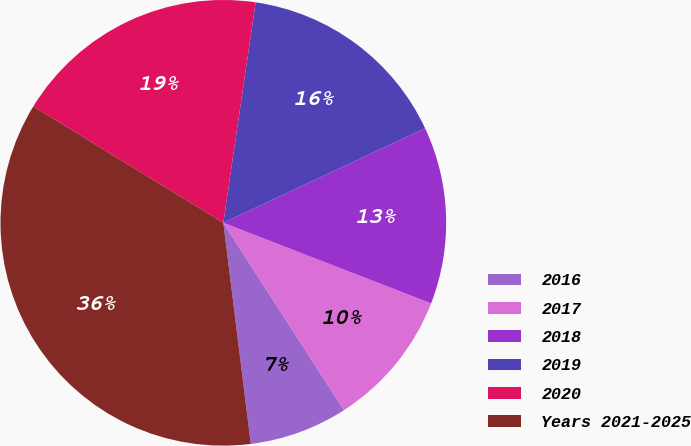<chart> <loc_0><loc_0><loc_500><loc_500><pie_chart><fcel>2016<fcel>2017<fcel>2018<fcel>2019<fcel>2020<fcel>Years 2021-2025<nl><fcel>7.14%<fcel>10.0%<fcel>12.86%<fcel>15.71%<fcel>18.57%<fcel>35.71%<nl></chart> 